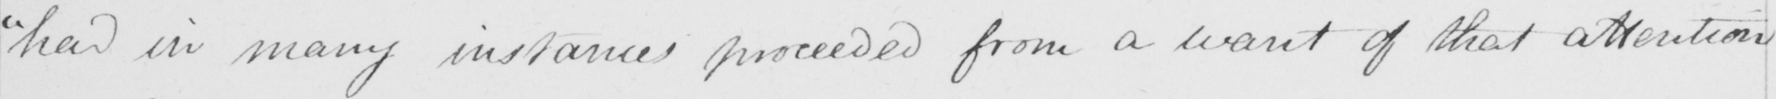Transcribe the text shown in this historical manuscript line. " had in many instances proceeded from a want of that attention 